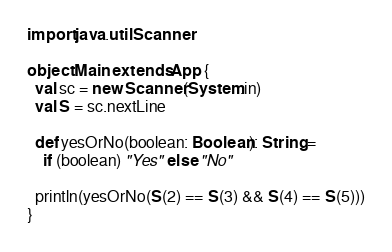<code> <loc_0><loc_0><loc_500><loc_500><_Scala_>import java.util.Scanner

object Main extends App {
  val sc = new Scanner(System.in)
  val S = sc.nextLine

  def yesOrNo(boolean: Boolean): String =
    if (boolean) "Yes" else "No"

  println(yesOrNo(S(2) == S(3) && S(4) == S(5)))
}
</code> 